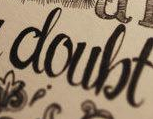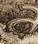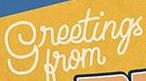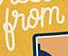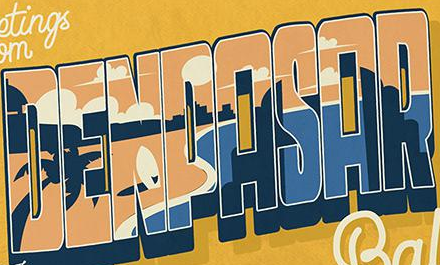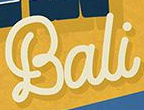Transcribe the words shown in these images in order, separated by a semicolon. doubt; a; greetings; from; DENPASAR; Bali 